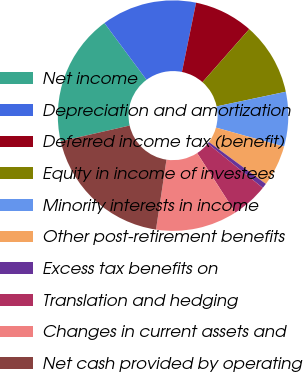<chart> <loc_0><loc_0><loc_500><loc_500><pie_chart><fcel>Net income<fcel>Depreciation and amortization<fcel>Deferred income tax (benefit)<fcel>Equity in income of investees<fcel>Minority interests in income<fcel>Other post-retirement benefits<fcel>Excess tax benefits on<fcel>Translation and hedging<fcel>Changes in current assets and<fcel>Net cash provided by operating<nl><fcel>18.43%<fcel>13.36%<fcel>8.29%<fcel>10.19%<fcel>7.66%<fcel>5.76%<fcel>0.69%<fcel>5.12%<fcel>11.46%<fcel>19.06%<nl></chart> 